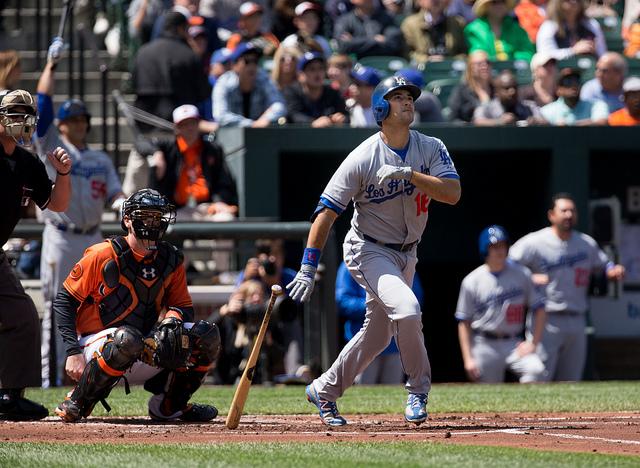What sport is this?
Give a very brief answer. Baseball. Did the batter strike out?
Give a very brief answer. No. What team are these players on?
Concise answer only. Los angeles. Is the batter going to run to first base?
Be succinct. Yes. 